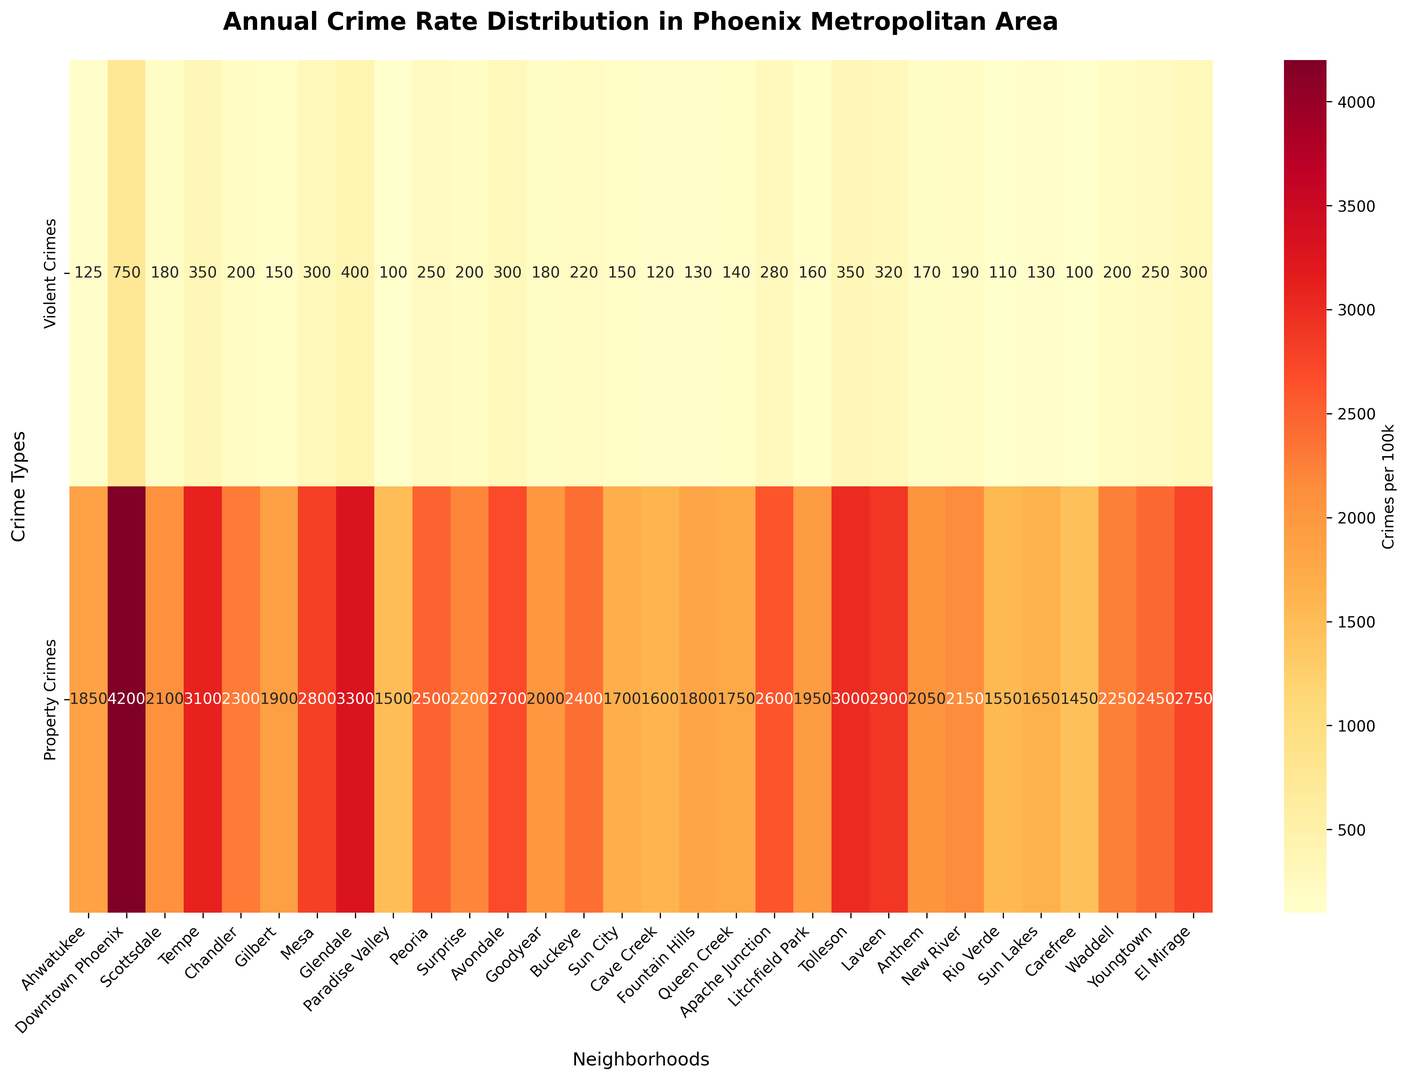What is the overall pattern of violent crimes and property crimes in Downtown Phoenix? Refer to the figure to observe the numerical values for Downtown Phoenix. It has 750 violent crimes per 100k and 4200 property crimes per 100k.
Answer: High for both crime types Which neighborhood has the highest violent crime rate, and what is the value? Scan the violent crimes row and identify the highest value, which is 750 for Downtown Phoenix.
Answer: Downtown Phoenix, 750 Compare the violent crime rate in Ahwatukee to the property crime rate in Ahwatukee. Ahwatukee has 125 violent crimes and 1850 property crimes per 100k. The property crime rate is significantly higher.
Answer: Property crimes are much higher How does the property crime rate in Tempe compare to that in Gilbert? Tempe has 3100 property crimes per 100k, while Gilbert has 1900. Thus, Tempe's property crime rate is higher.
Answer: Higher in Tempe Which neighborhoods have the lowest violent crime rates, and what are they? Look for the smallest values in the violent crimes row, identifying 100 in Paradise Valley and Carefree.
Answer: Paradise Valley and Carefree, 100 Calculate the average property crime rate across all neighborhoods. Sum the property crime rates for all neighborhoods and divide by the number of neighborhoods: (1850 + 4200 + 2100 + 3100 + 2300 + 1900 + 2800 + 3300 + 1500 + 2500 + 2200 + 2700 + 2000 + 2400 + 1700 + 1600 + 1800 + 1750 + 2600 + 1950 + 3000 + 2900 + 2050 + 2150 + 1550 + 1650 + 1450 + 2250 + 2450 + 2750)/30 = 2346.5 .
Answer: 2346.5 Which neighborhood has a more balanced crime rate between violent and property crimes? Examine the ratios between violent and property crimes. Sun City has 150/1700 and Buckeye has 220/2400, both relatively balanced, but Buckeye is closer.
Answer: Buckeye What is the difference in property crime rates between Glendale and Peoria? Subtract Peoria's property crime rate (2500) from Glendale's (3300): 3300 - 2500 = 800.
Answer: 800 Which neighborhood has the highest property crime rate, and what is the value? Identify the largest value in the property crimes row, which is 4200 in Downtown Phoenix.
Answer: Downtown Phoenix, 4200 What color represents the highest crime rates on the heatmap? Based on the general heatmap color scheme, the highest values are usually represented by the darkest red.
Answer: Dark red 